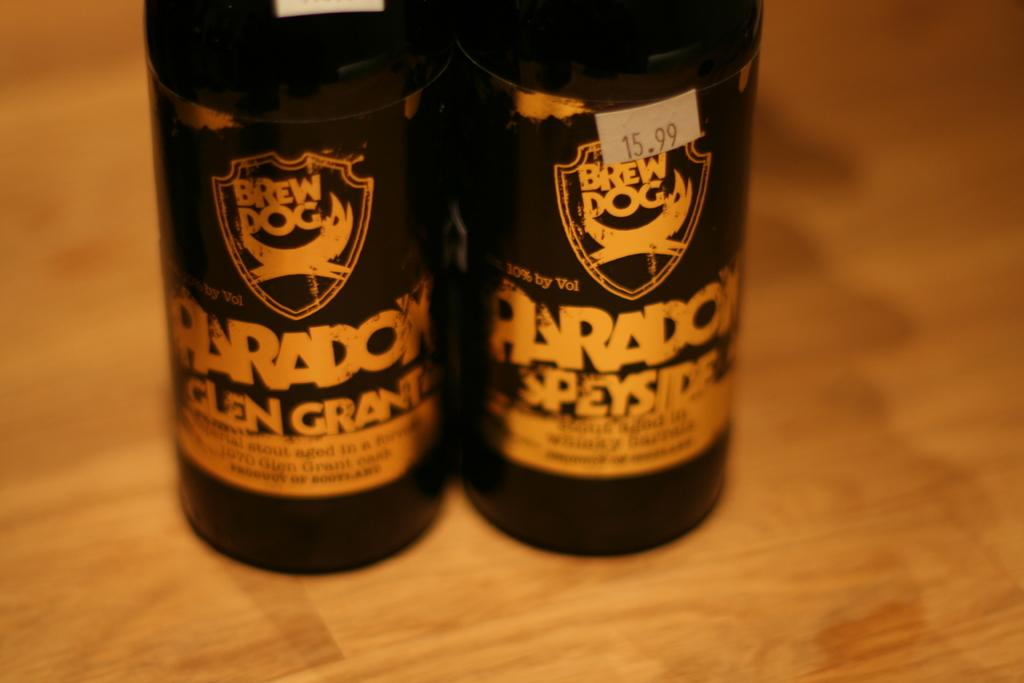Provide a one-sentence caption for the provided image. A couple of Brew Dog bottles have Paradox on the label. 